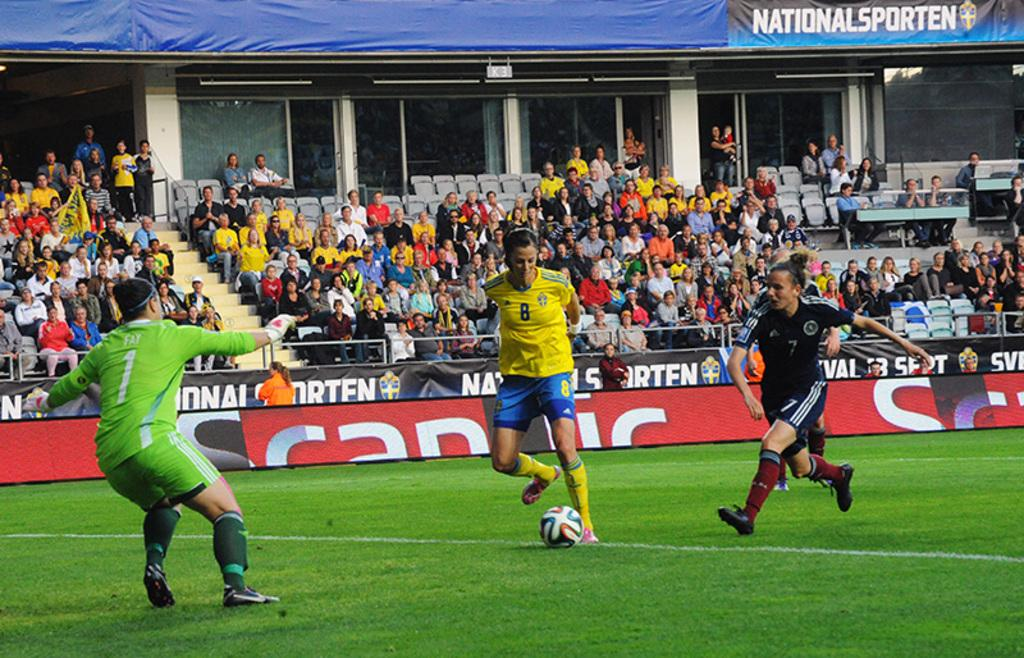<image>
Summarize the visual content of the image. Soccer players are on a field with the word national on a sign behind them. 